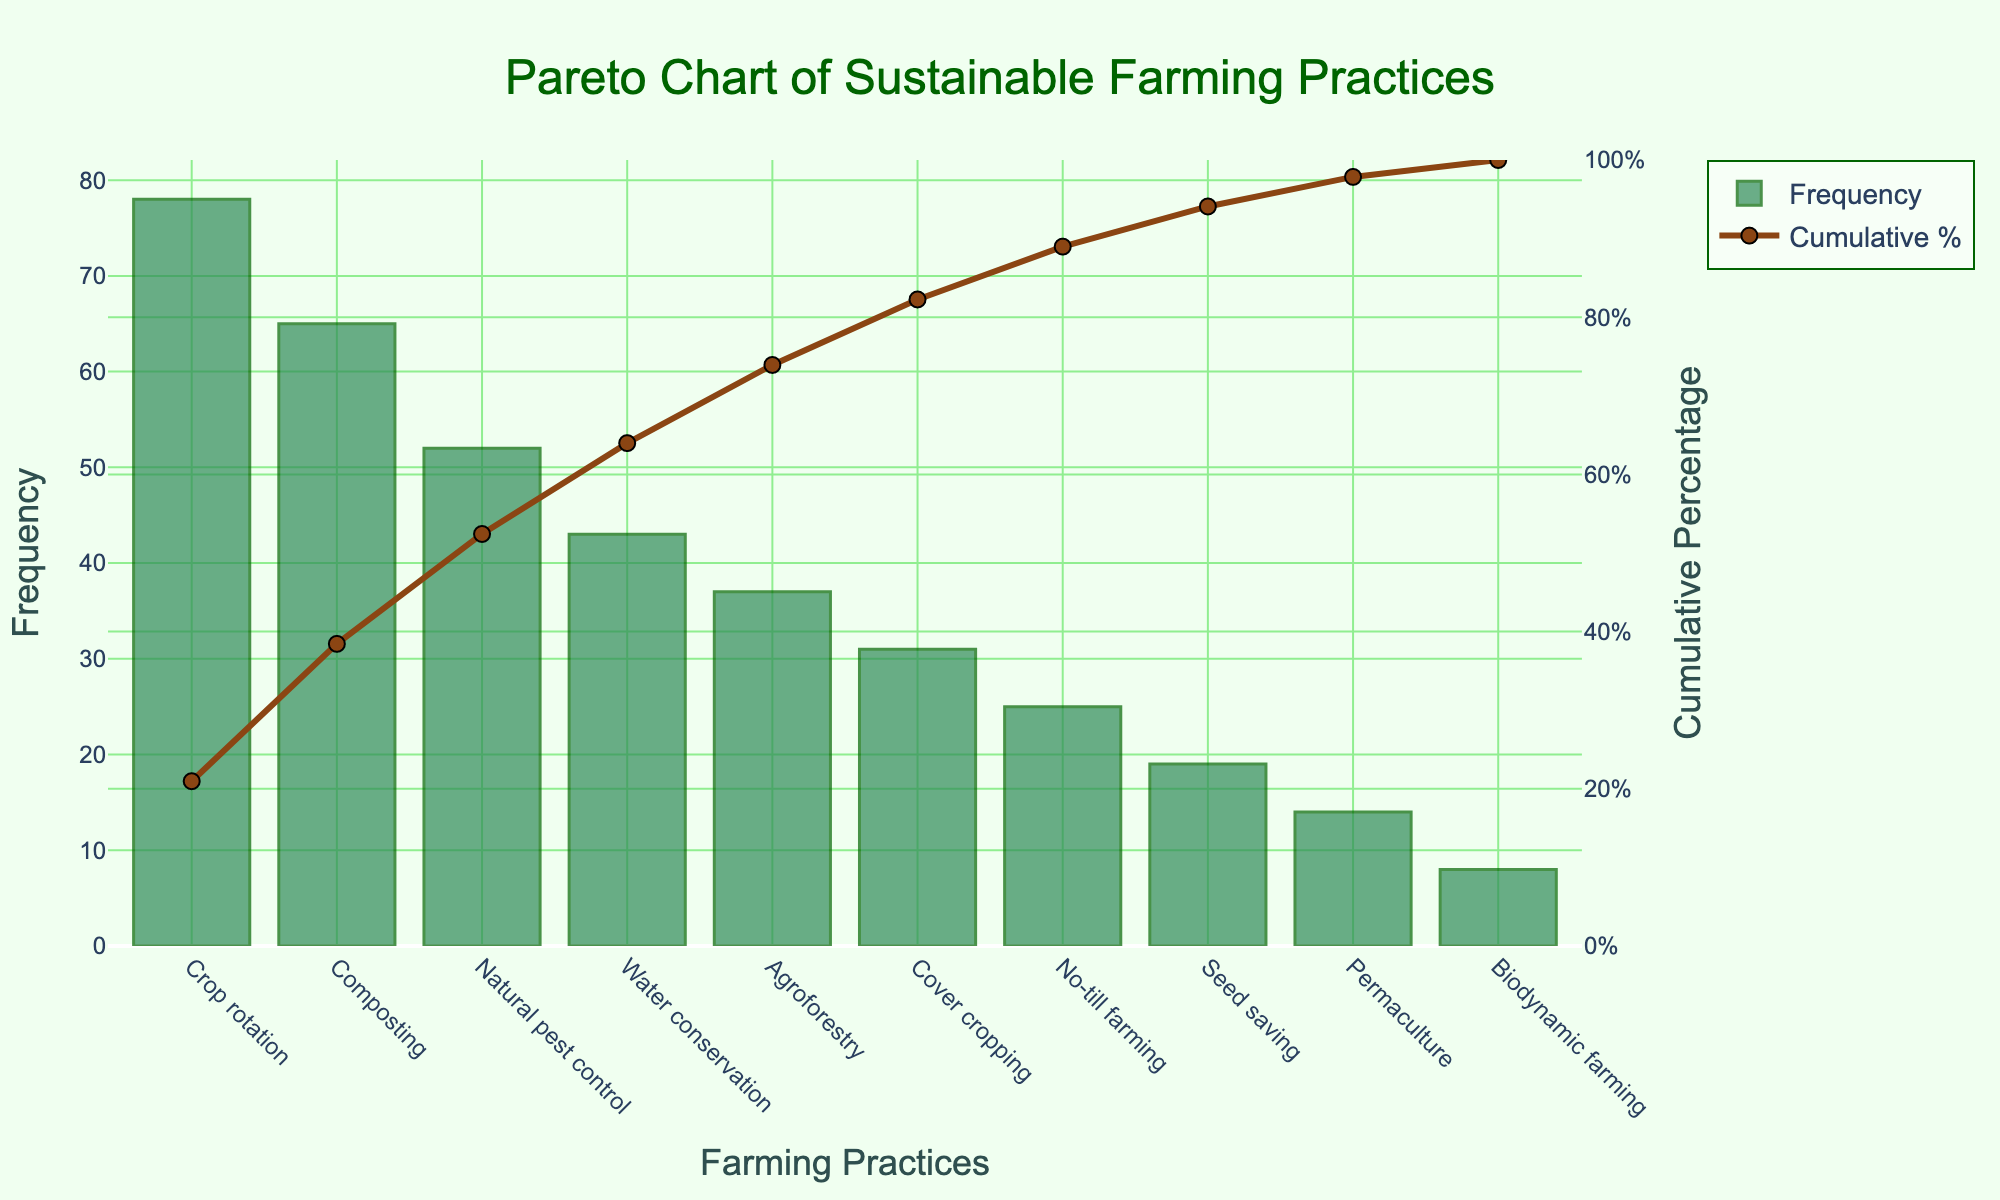What's the title of the chart? The title is located at the top of the chart and is centered. It reads 'Pareto Chart of Sustainable Farming Practices'.
Answer: Pareto Chart of Sustainable Farming Practices Which farming practice has the highest frequency? The bars represent the frequency of each practice, with the tallest bar indicating the highest frequency. The highest bar is for 'Crop rotation' with a frequency value of 78.
Answer: Crop rotation What is the cumulative percentage for 'Natural pest control'? The cumulative percentage line plots this information. Trace the line to the 'Natural pest control' point on the x-axis and read off the value from the right y-axis, which is approximately 68%.
Answer: 68% How many farming practices have a frequency greater than 30? Examine the heights of the bars and count the number of practices with heights greater than the 30 mark on the left y-axis. The practices are 'Crop rotation', 'Composting', 'Natural pest control', 'Water conservation', 'Agroforestry', and 'Cover cropping'.
Answer: Six What is the combined frequency of 'No-till farming' and 'Seed saving'? Locate both 'No-till farming' and 'Seed saving' on the x-axis and note their frequencies, which are 25 and 19, respectively. Add them together, 25 + 19 = 44.
Answer: 44 Which farming practice has the lowest frequency and what is its value? Find the shortest bar on the chart which represents the lowest frequency. This bar is 'Biodynamic farming' with a frequency value of 8.
Answer: Biodynamic farming, 8 What percentage of the total practices uses 'Water conservation' or more frequent practices? Identify 'Water conservation' and all practices to its left on the x-axis. These include 'Crop rotation', 'Composting', 'Natural pest control', and 'Water conservation'. Sum their frequencies: 78 + 65 + 52 + 43 = 238. The total frequency is 372. Calculate the percentage: (238 / 372) * 100 ≈ 64%.
Answer: 64% Compare the frequencies of 'Agroforestry' and 'Cover cropping'. Which is higher and by how much? Check the height of the bars for 'Agroforestry' and 'Cover cropping'. 'Agroforestry' has a frequency of 37, and 'Cover cropping' has a frequency of 31. Subtract their values, 37 - 31 = 6.
Answer: Agroforestry by 6 What's the cumulative frequency for the first three practices? The first three practices are 'Crop rotation', 'Composting', and 'Natural pest control'. Sum their frequencies: 78 + 65 + 52 = 195.
Answer: 195 What is the value of the cumulative percentage at the point where 'Cover cropping' is represented? Following the cumulative percentage line to 'Cover cropping', the value on the right y-axis is seen to be around 78%.
Answer: 78% 